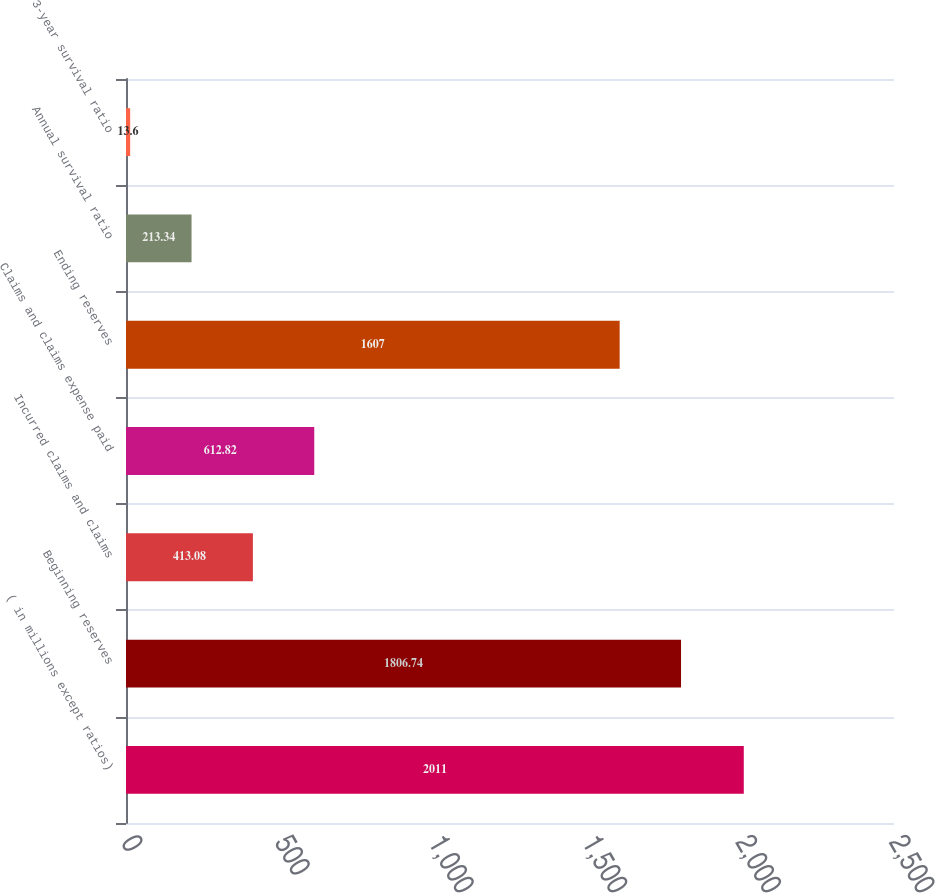Convert chart. <chart><loc_0><loc_0><loc_500><loc_500><bar_chart><fcel>( in millions except ratios)<fcel>Beginning reserves<fcel>Incurred claims and claims<fcel>Claims and claims expense paid<fcel>Ending reserves<fcel>Annual survival ratio<fcel>3-year survival ratio<nl><fcel>2011<fcel>1806.74<fcel>413.08<fcel>612.82<fcel>1607<fcel>213.34<fcel>13.6<nl></chart> 